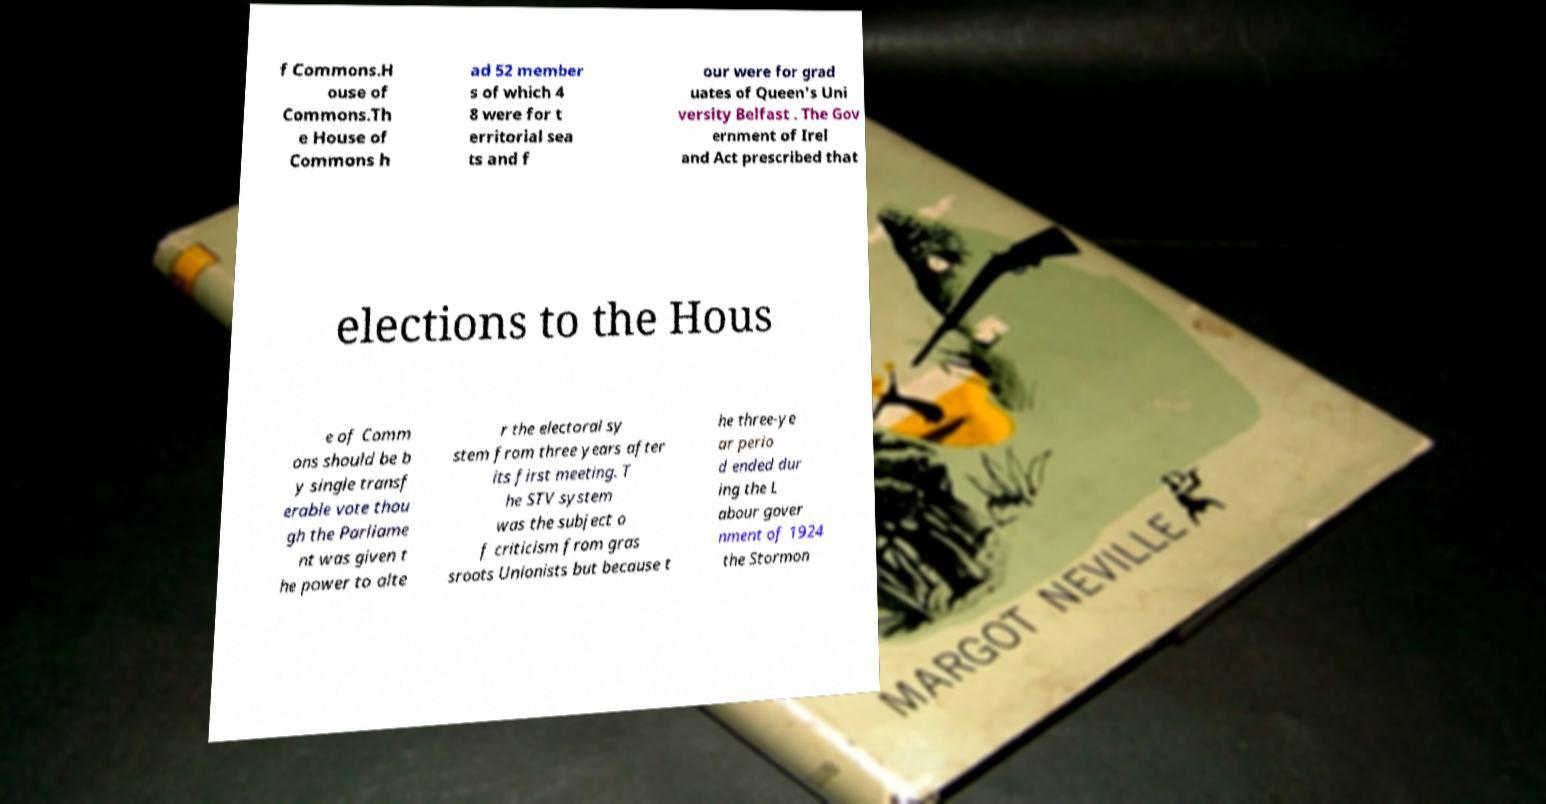Can you accurately transcribe the text from the provided image for me? f Commons.H ouse of Commons.Th e House of Commons h ad 52 member s of which 4 8 were for t erritorial sea ts and f our were for grad uates of Queen's Uni versity Belfast . The Gov ernment of Irel and Act prescribed that elections to the Hous e of Comm ons should be b y single transf erable vote thou gh the Parliame nt was given t he power to alte r the electoral sy stem from three years after its first meeting. T he STV system was the subject o f criticism from gras sroots Unionists but because t he three-ye ar perio d ended dur ing the L abour gover nment of 1924 the Stormon 